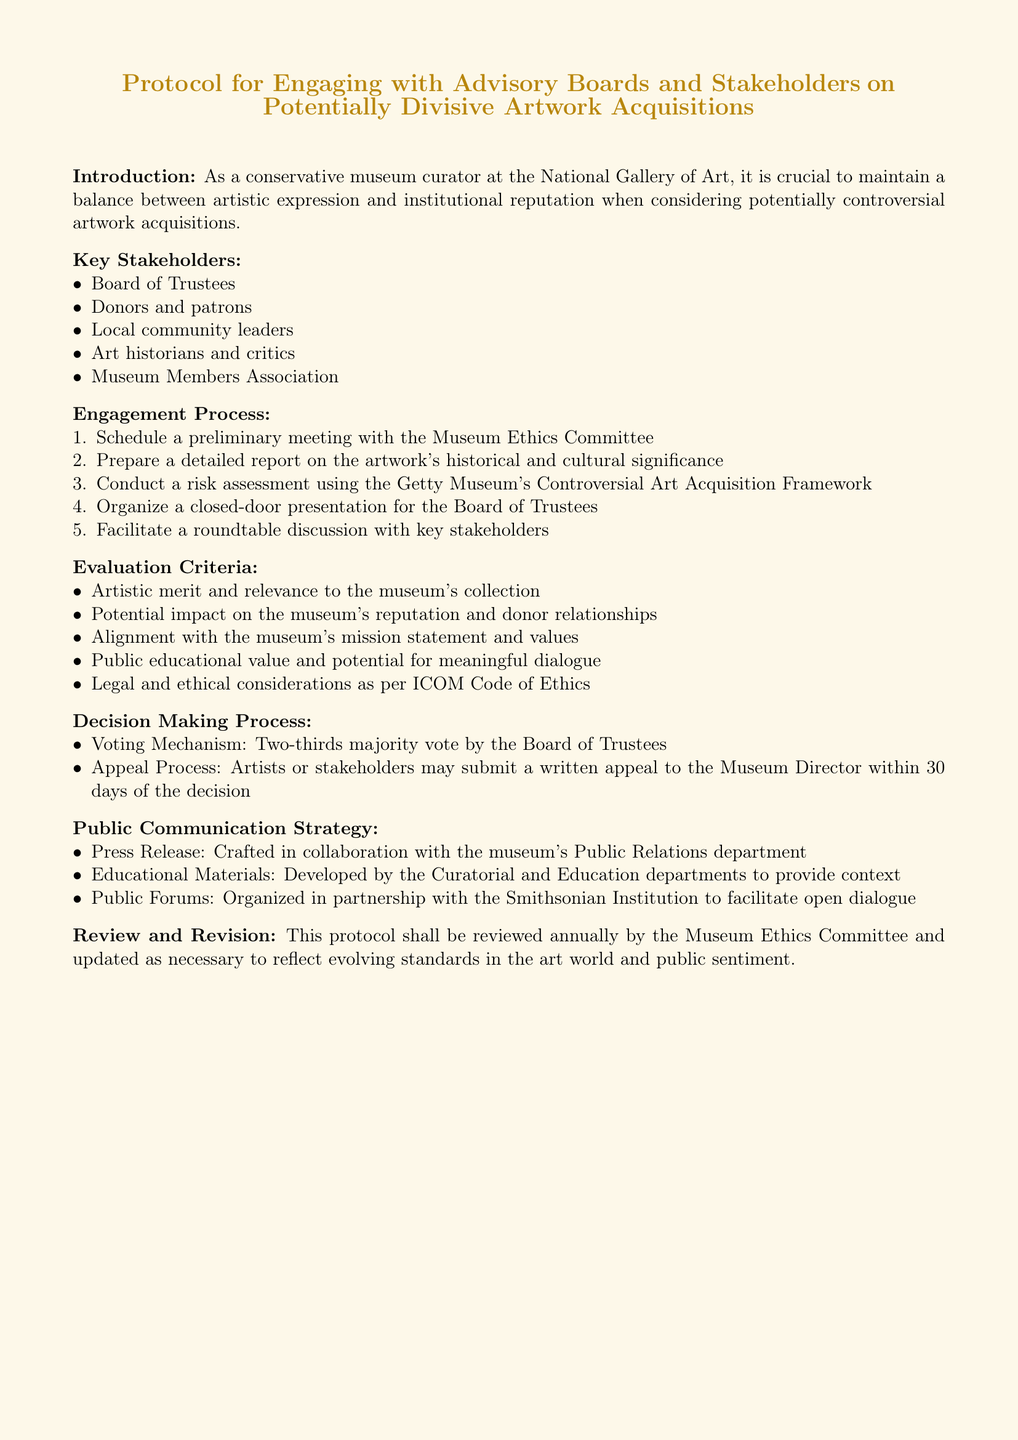What is the title of the document? The title of the document is presented prominently at the beginning and outlines its purpose regarding artwork acquisitions.
Answer: Protocol for Engaging with Advisory Boards and Stakeholders on Potentially Divisive Artwork Acquisitions Who should conduct a preliminary meeting? The introduction of the protocol specifies that the Museum Ethics Committee is responsible for initial discussions.
Answer: Museum Ethics Committee What is the voting mechanism for the decision-making process? The document details the requirements for voting on acquisitions by the Board of Trustees, highlighting the necessary majority.
Answer: Two-thirds majority vote How often will this protocol be reviewed? In the review section, a specific frequency for evaluation of the protocol is mentioned.
Answer: Annually What kind of educational materials will be developed? The document specifies that these materials aim to provide context regarding the acquisitions and are crafted by certain departments.
Answer: Contextual educational materials What is one evaluation criterion for artwork acquisitions? The evaluation criteria encompass various considerations that support decision-making, including artistic and reputational factors.
Answer: Artistic merit and relevance to the museum's collection Which institution is mentioned for organizing public forums? The strategy for public communication includes collaborations with other organizations for dialogue regarding acquisitions.
Answer: Smithsonian Institution What must stakeholders submit if they want to appeal a decision? The process for appeals indicates the required form of communication from artists or stakeholders who disagree with the initial decision.
Answer: Written appeal 